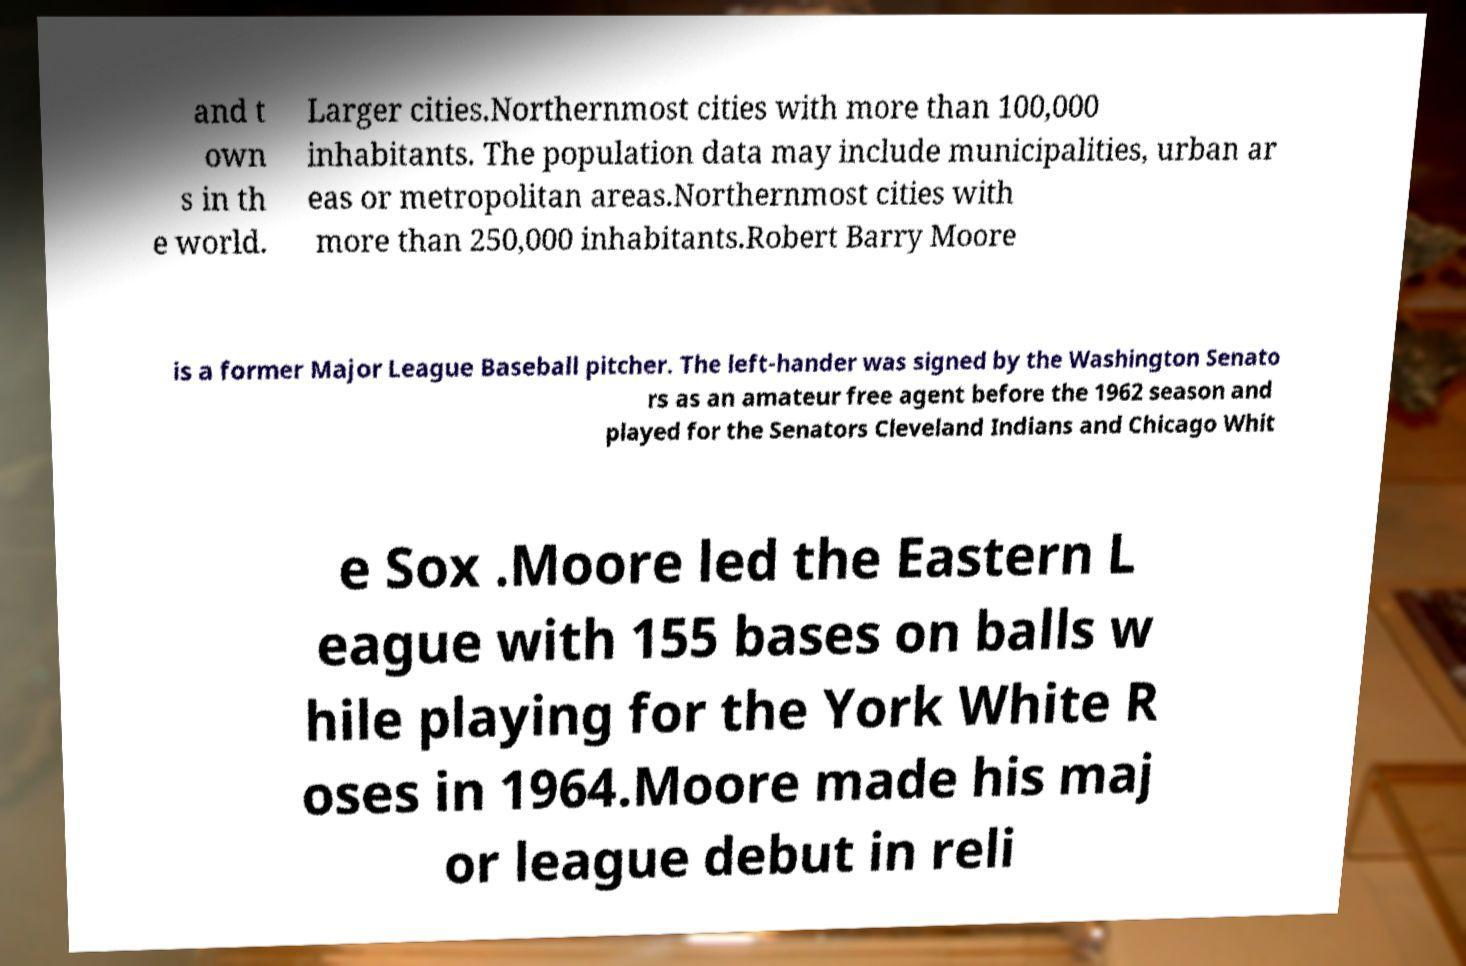What messages or text are displayed in this image? I need them in a readable, typed format. and t own s in th e world. Larger cities.Northernmost cities with more than 100,000 inhabitants. The population data may include municipalities, urban ar eas or metropolitan areas.Northernmost cities with more than 250,000 inhabitants.Robert Barry Moore is a former Major League Baseball pitcher. The left-hander was signed by the Washington Senato rs as an amateur free agent before the 1962 season and played for the Senators Cleveland Indians and Chicago Whit e Sox .Moore led the Eastern L eague with 155 bases on balls w hile playing for the York White R oses in 1964.Moore made his maj or league debut in reli 